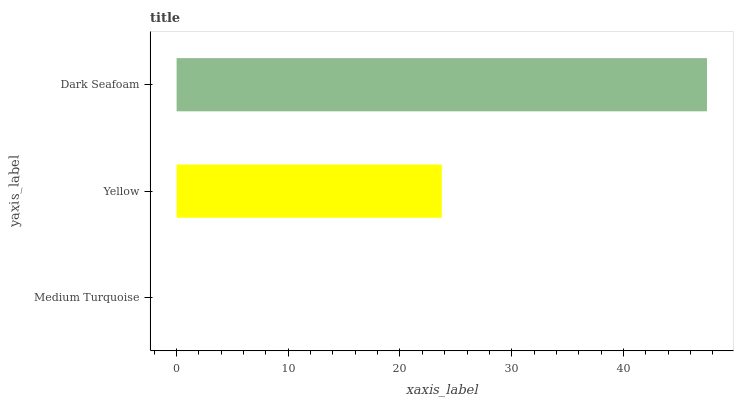Is Medium Turquoise the minimum?
Answer yes or no. Yes. Is Dark Seafoam the maximum?
Answer yes or no. Yes. Is Yellow the minimum?
Answer yes or no. No. Is Yellow the maximum?
Answer yes or no. No. Is Yellow greater than Medium Turquoise?
Answer yes or no. Yes. Is Medium Turquoise less than Yellow?
Answer yes or no. Yes. Is Medium Turquoise greater than Yellow?
Answer yes or no. No. Is Yellow less than Medium Turquoise?
Answer yes or no. No. Is Yellow the high median?
Answer yes or no. Yes. Is Yellow the low median?
Answer yes or no. Yes. Is Dark Seafoam the high median?
Answer yes or no. No. Is Dark Seafoam the low median?
Answer yes or no. No. 